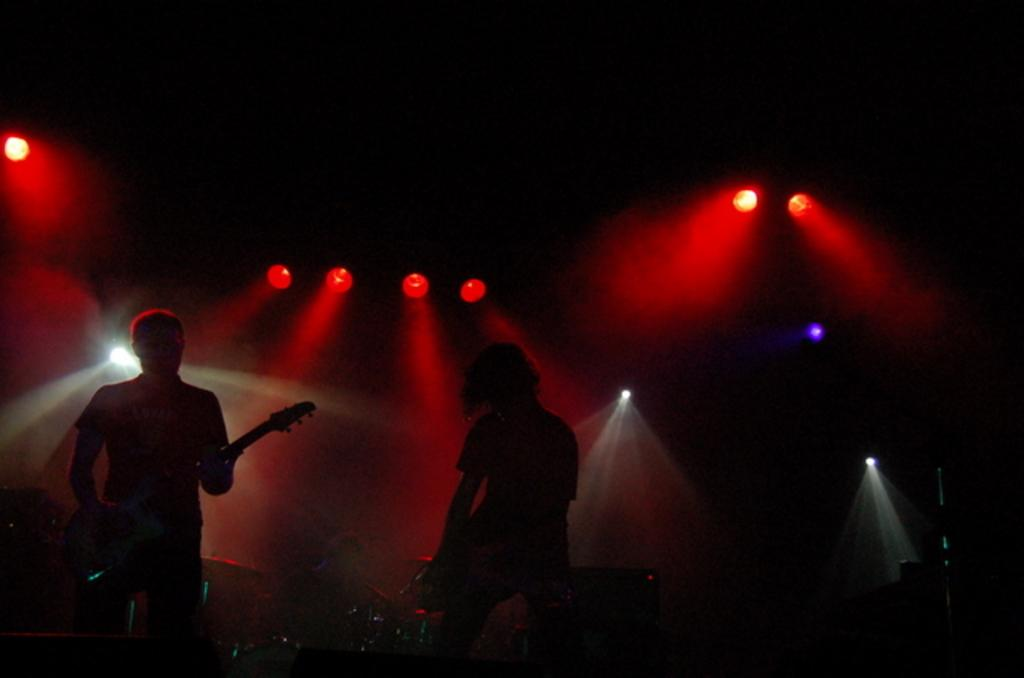How many people are in the image? There are two persons in the image. What are the persons doing in the image? The persons are playing musical instruments. Can you describe the lighting in the image? There are lights on the ceiling in the image. What are the hobbies of the person playing the guitar in the image? There is no information about the person's hobbies in the image, as it only shows them playing a musical instrument. What is the name of the person playing the drums in the image? There is no information about the person's name in the image, as it only shows them playing a musical instrument. 